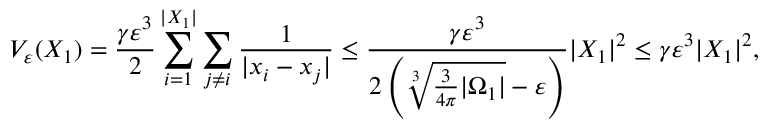<formula> <loc_0><loc_0><loc_500><loc_500>V _ { \varepsilon } ( X _ { 1 } ) = \frac { \gamma \varepsilon ^ { 3 } } { 2 } \sum _ { i = 1 } ^ { | X _ { 1 } | } \sum _ { j \neq i } \frac { 1 } { | x _ { i } - x _ { j } | } \leq \frac { \gamma \varepsilon ^ { 3 } } { 2 \left ( \sqrt { [ } 3 ] { \frac { 3 } { 4 \pi } | \Omega _ { 1 } | } - \varepsilon \right ) } | X _ { 1 } | ^ { 2 } \leq \gamma \varepsilon ^ { 3 } | X _ { 1 } | ^ { 2 } ,</formula> 